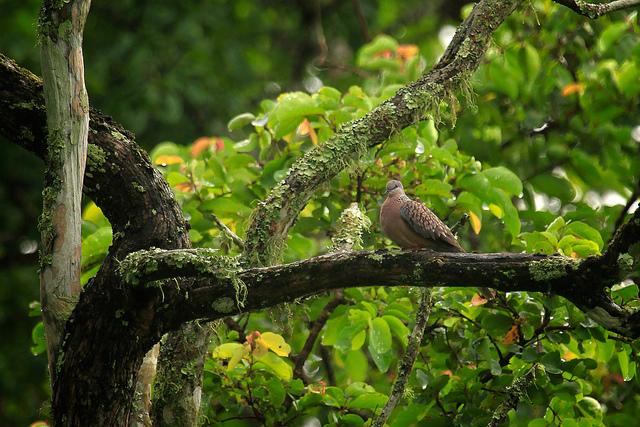What color are the leaves?
Answer briefly. Green. How many birds are in the picture?
Concise answer only. 1. What species of bird is this?
Write a very short answer. Dove. Do these birds live in the jungle?
Concise answer only. No. What kind of bird is this?
Concise answer only. Dove. Is the bird facing the camera?
Be succinct. No. What are the birds doing?
Keep it brief. Sitting. What color are the birds eyes?
Quick response, please. Black. How many birds on the tree?
Short answer required. 1. Where is the bird feeding?
Quick response, please. Tree. 